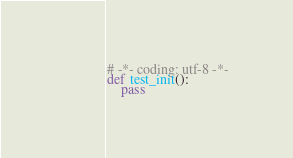Convert code to text. <code><loc_0><loc_0><loc_500><loc_500><_Python_># -*- coding: utf-8 -*-
def test_init():
    pass
</code> 